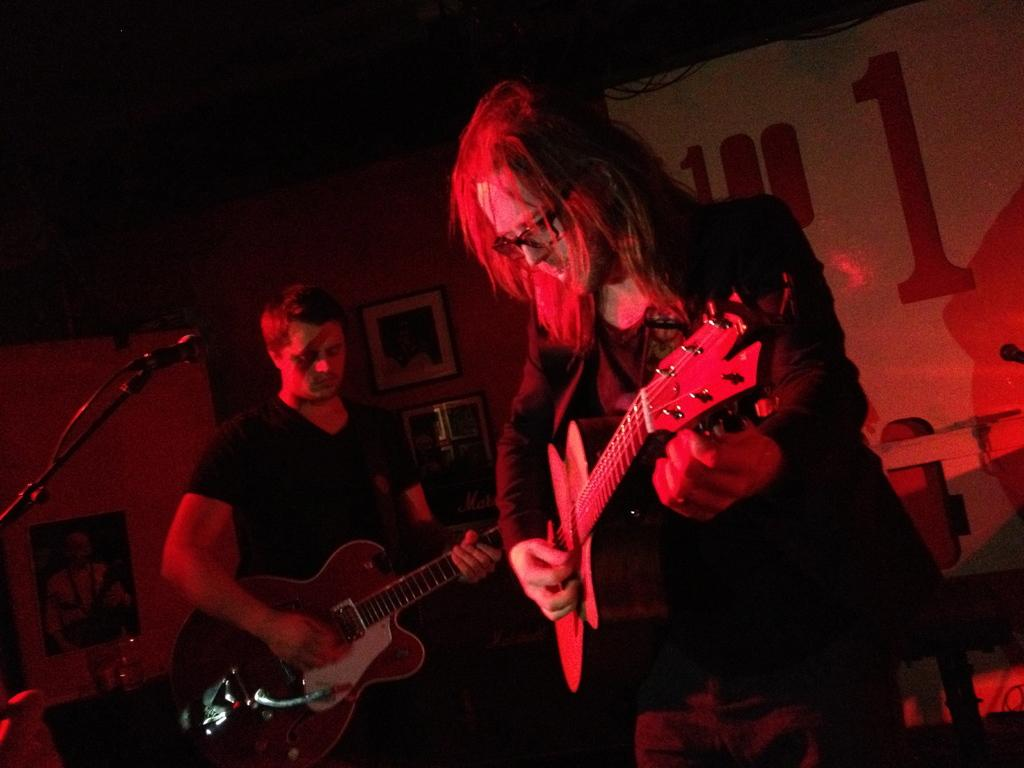How many people are in the image? There are two persons standing in the image. What are the persons holding in the image? The persons are holding guitars. What equipment is present for amplifying sound in the image? There is a microphone with a stand in the image. What can be seen in the background of the image? There is a wall, a photo frame, and a banner in the background of the image. What type of religious artifact is present in the image? There is no religious artifact present in the image. Can you tell me where the library is located in the image? There is no library present in the image. 